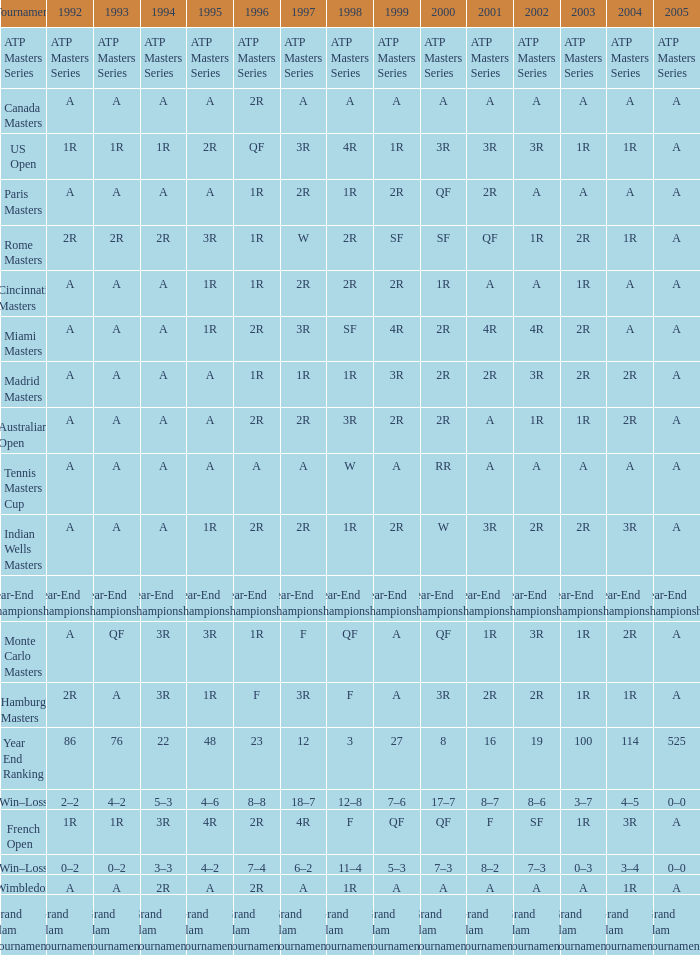What is Tournament, when 2000 is "A"? Wimbledon, Canada Masters. 